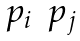Convert formula to latex. <formula><loc_0><loc_0><loc_500><loc_500>\begin{matrix} p _ { i } & p _ { j } \\ \end{matrix}</formula> 